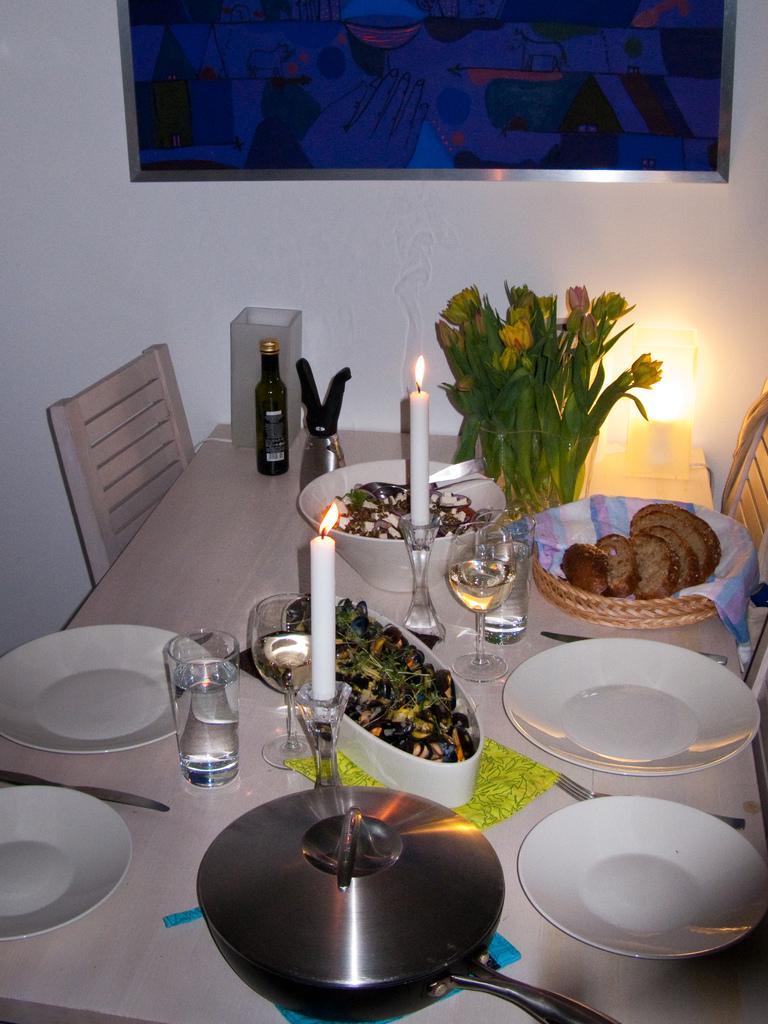Could you give a brief overview of what you see in this image? In this picture I can see the table in front on which there are plates, candles, glasses, flowers, a bottle, lights and I see the bowls and a basket on which there is food. In the background I see the wall and I see the frame which is of blue and black color. 